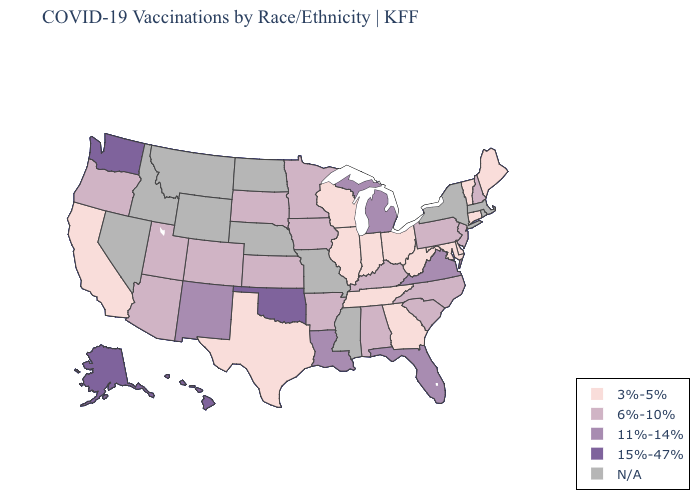Does the first symbol in the legend represent the smallest category?
Answer briefly. Yes. What is the lowest value in the USA?
Give a very brief answer. 3%-5%. Name the states that have a value in the range 15%-47%?
Keep it brief. Alaska, Hawaii, Oklahoma, Washington. What is the lowest value in states that border Montana?
Quick response, please. 6%-10%. What is the lowest value in states that border South Carolina?
Be succinct. 3%-5%. What is the highest value in the South ?
Keep it brief. 15%-47%. What is the value of South Dakota?
Give a very brief answer. 6%-10%. How many symbols are there in the legend?
Be succinct. 5. Which states hav the highest value in the MidWest?
Give a very brief answer. Michigan. What is the value of South Carolina?
Be succinct. 6%-10%. Among the states that border Minnesota , does Wisconsin have the highest value?
Be succinct. No. What is the lowest value in the South?
Short answer required. 3%-5%. What is the highest value in the South ?
Quick response, please. 15%-47%. What is the value of Rhode Island?
Keep it brief. N/A. 